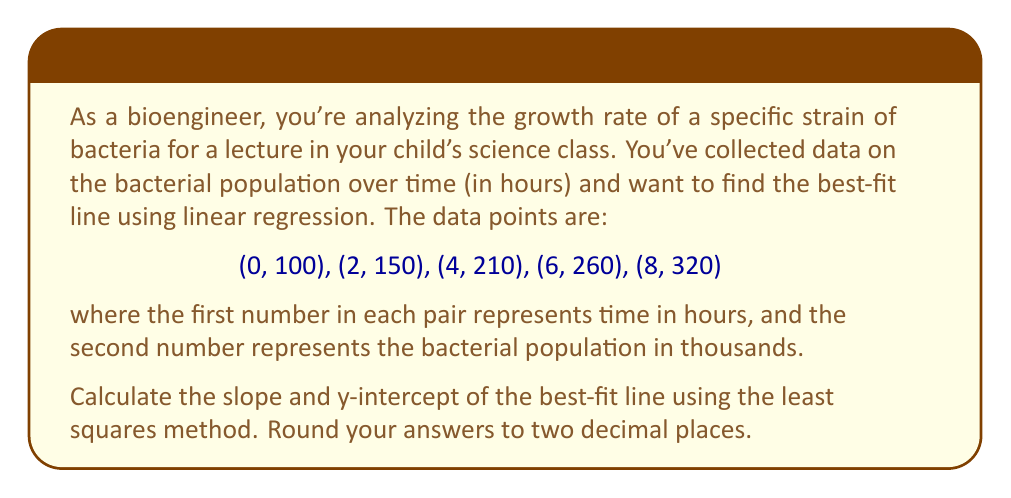Show me your answer to this math problem. To find the best-fit line using linear regression, we'll use the least squares method. The formula for the slope (m) and y-intercept (b) are:

$$m = \frac{n\sum xy - \sum x \sum y}{n\sum x^2 - (\sum x)^2}$$

$$b = \frac{\sum y - m\sum x}{n}$$

Where n is the number of data points.

Let's calculate the necessary sums:

$n = 5$
$\sum x = 0 + 2 + 4 + 6 + 8 = 20$
$\sum y = 100 + 150 + 210 + 260 + 320 = 1040$
$\sum xy = 0(100) + 2(150) + 4(210) + 6(260) + 8(320) = 4680$
$\sum x^2 = 0^2 + 2^2 + 4^2 + 6^2 + 8^2 = 120$

Now, let's substitute these values into the slope formula:

$$m = \frac{5(4680) - 20(1040)}{5(120) - 20^2}$$
$$m = \frac{23400 - 20800}{600 - 400}$$
$$m = \frac{2600}{200} = 13$$

Next, let's calculate the y-intercept:

$$b = \frac{1040 - 13(20)}{5}$$
$$b = \frac{1040 - 260}{5}$$
$$b = \frac{780}{5} = 156$$

Therefore, the equation of the best-fit line is:

$$y = 13x + 156$$

Where $y$ represents the bacterial population in thousands, and $x$ represents the time in hours.
Answer: Slope (m) = 13.00
Y-intercept (b) = 156.00 